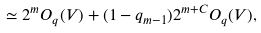Convert formula to latex. <formula><loc_0><loc_0><loc_500><loc_500>\simeq 2 ^ { m } O _ { q } ( V ) + ( 1 - q _ { m - 1 } ) 2 ^ { m + C } O _ { q } ( V ) ,</formula> 